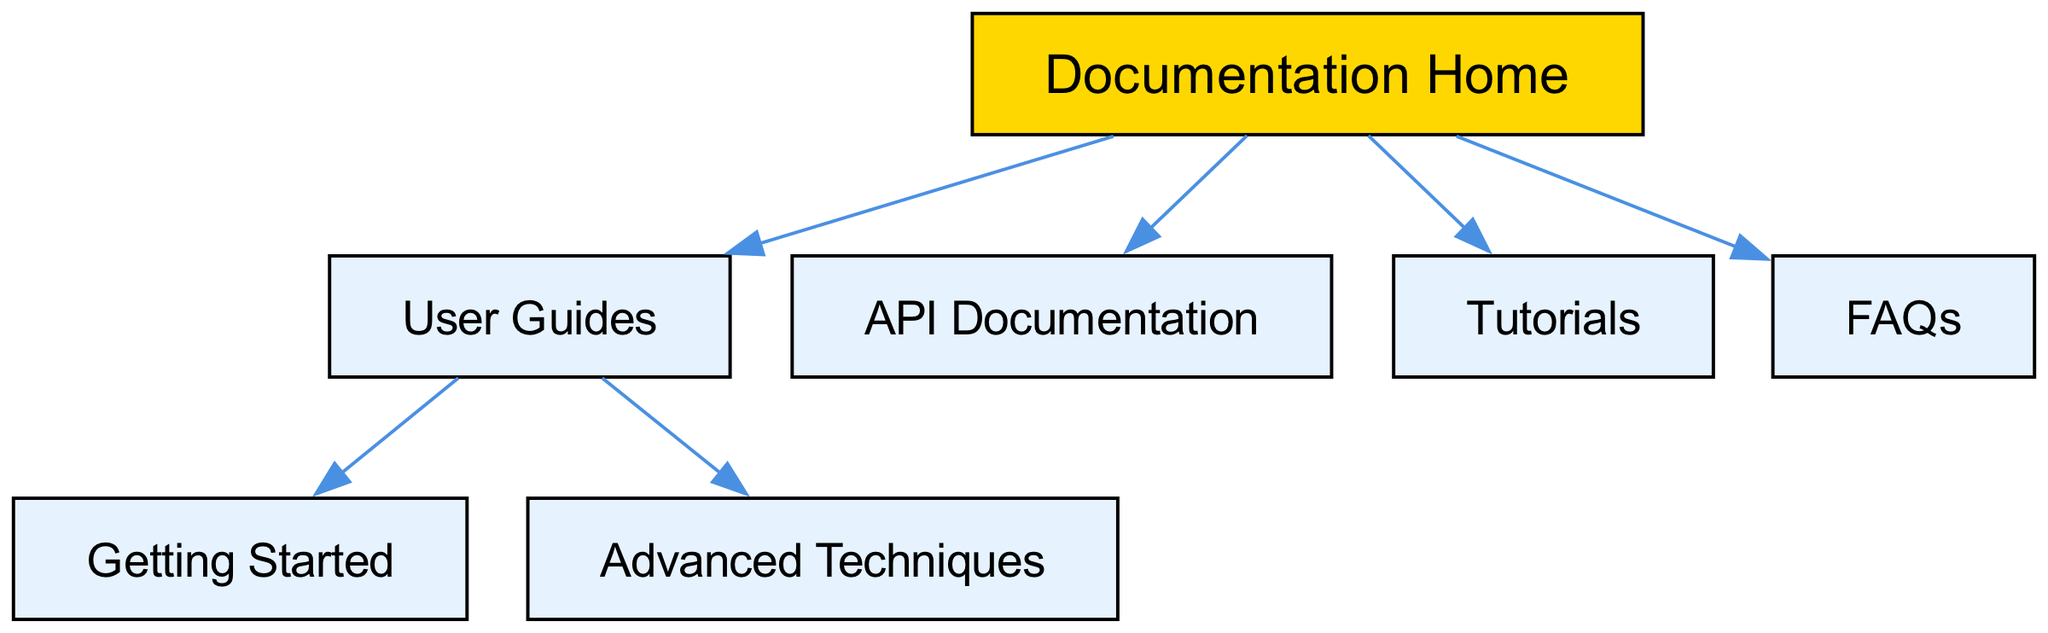What is the main node in the diagram? The main node is "Documentation Home," as it serves as the root node from which all other nodes connect.
Answer: Documentation Home How many nodes are present in the diagram? By counting all individual nodes, we find there are a total of seven distinct nodes in the diagram.
Answer: 7 Which nodes are directly connected to "User Guides"? The nodes "Getting Started" and "Advanced Techniques" are connected directly to "User Guides," as depicted by arrows leading from "User Guides" to these two nodes.
Answer: Getting Started, Advanced Techniques What is the connection between "Documentation Home" and "FAQs"? "Documentation Home" connects directly to "FAQs," indicating that FAQs is a resource available directly from the documentation home.
Answer: Direct connection How many edges are there in the diagram? To find the number of edges, we count the connections made from one node to another, resulting in a total of six edges present in the diagram.
Answer: 6 Which node serves as a subgroup under "User Guides"? The subgroup under "User Guides" consists of "Getting Started" and "Advanced Techniques," indicating that these topics fall under the user guide category.
Answer: Getting Started, Advanced Techniques What type of information would you find in "API Documentation"? "API Documentation" typically contains details and references related to the application programming interface, including methods, endpoints, and usage examples.
Answer: API details Is "Tutorials" a top-level node or a subgroup? "Tutorials" is a top-level node as it is directly connected to the "Documentation Home" and does not fall under any other category in this structure.
Answer: Top-level node 